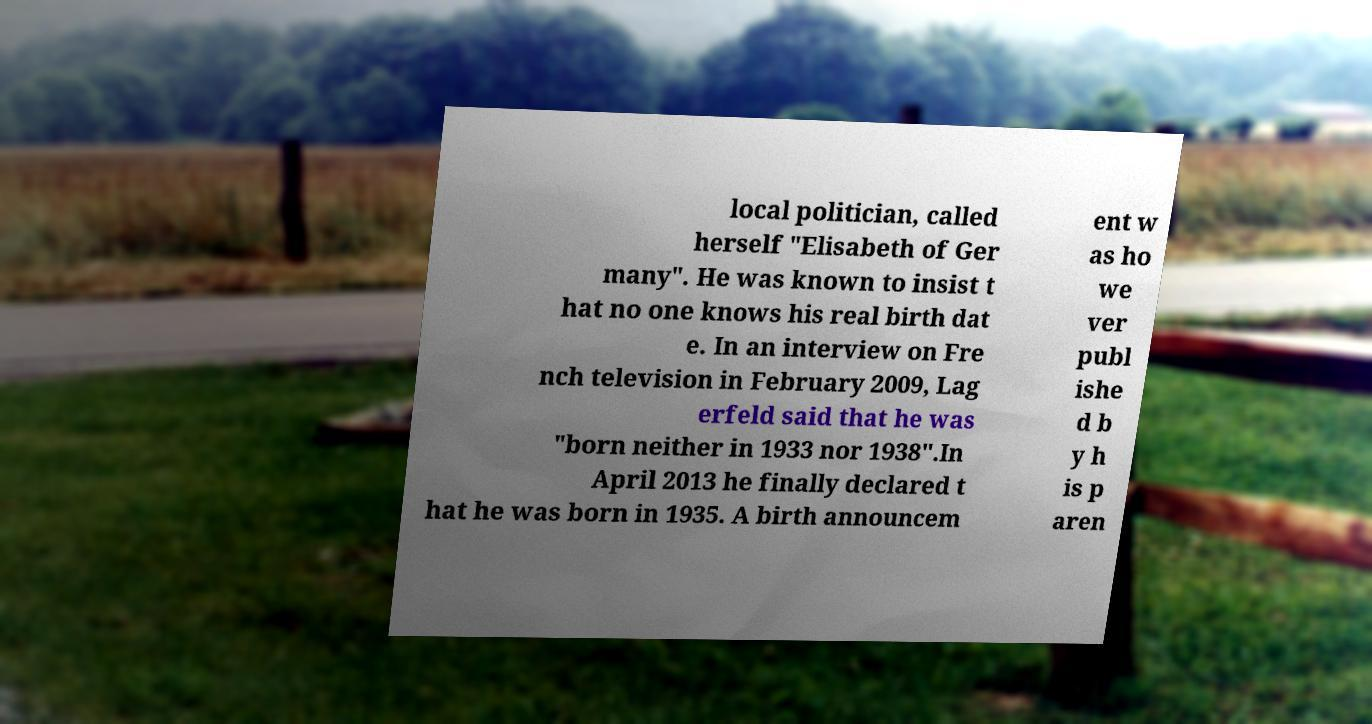Can you accurately transcribe the text from the provided image for me? local politician, called herself "Elisabeth of Ger many". He was known to insist t hat no one knows his real birth dat e. In an interview on Fre nch television in February 2009, Lag erfeld said that he was "born neither in 1933 nor 1938".In April 2013 he finally declared t hat he was born in 1935. A birth announcem ent w as ho we ver publ ishe d b y h is p aren 